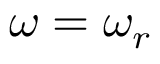Convert formula to latex. <formula><loc_0><loc_0><loc_500><loc_500>\omega = \omega _ { r }</formula> 